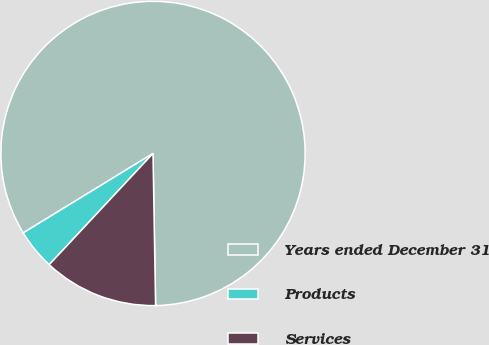<chart> <loc_0><loc_0><loc_500><loc_500><pie_chart><fcel>Years ended December 31<fcel>Products<fcel>Services<nl><fcel>83.47%<fcel>4.31%<fcel>12.22%<nl></chart> 